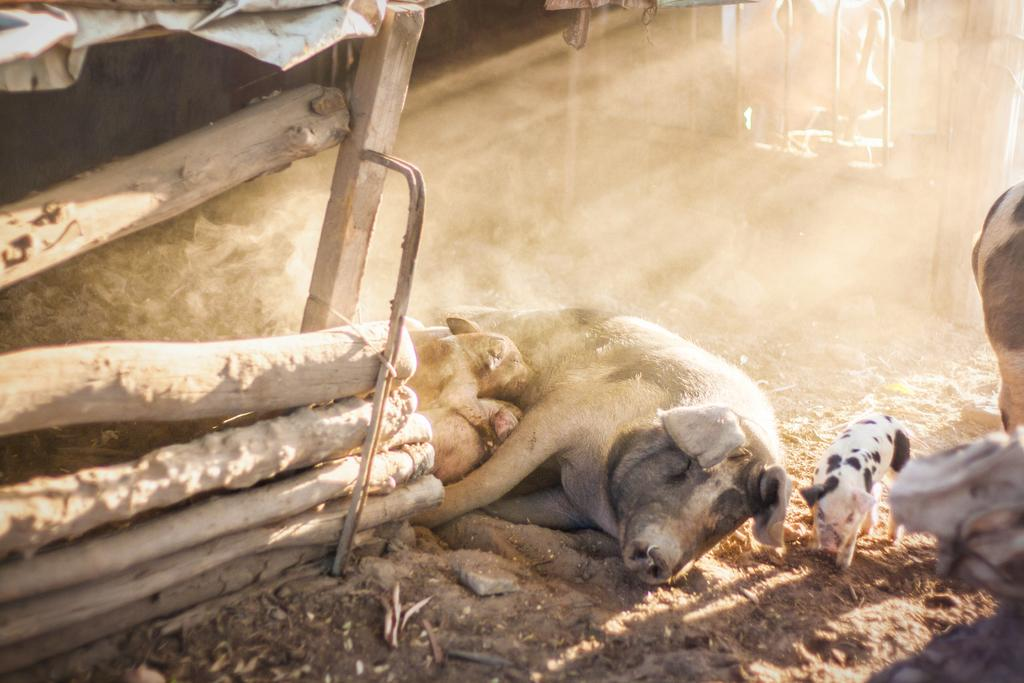What animals are on the ground in the image? There are pigs on the ground in the image. What type of objects are made of wood in the image? There are wooden objects in the image. What type of crime is being committed by the pigs in the image? There is no indication of any crime being committed in the image; it simply features pigs on the ground and wooden objects. What color is the yarn used to create the wooden objects in the image? There is no yarn present in the image, as the wooden objects are not described as being made of yarn. 